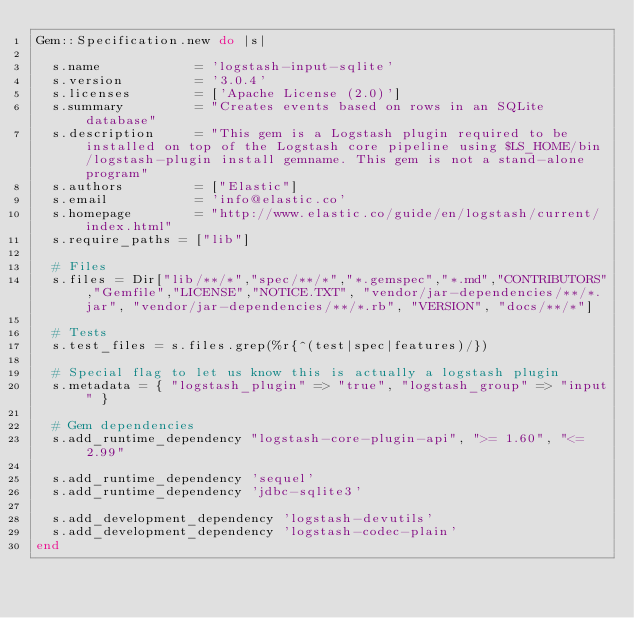Convert code to text. <code><loc_0><loc_0><loc_500><loc_500><_Ruby_>Gem::Specification.new do |s|

  s.name            = 'logstash-input-sqlite'
  s.version         = '3.0.4'
  s.licenses        = ['Apache License (2.0)']
  s.summary         = "Creates events based on rows in an SQLite database"
  s.description     = "This gem is a Logstash plugin required to be installed on top of the Logstash core pipeline using $LS_HOME/bin/logstash-plugin install gemname. This gem is not a stand-alone program"
  s.authors         = ["Elastic"]
  s.email           = 'info@elastic.co'
  s.homepage        = "http://www.elastic.co/guide/en/logstash/current/index.html"
  s.require_paths = ["lib"]

  # Files
  s.files = Dir["lib/**/*","spec/**/*","*.gemspec","*.md","CONTRIBUTORS","Gemfile","LICENSE","NOTICE.TXT", "vendor/jar-dependencies/**/*.jar", "vendor/jar-dependencies/**/*.rb", "VERSION", "docs/**/*"]

  # Tests
  s.test_files = s.files.grep(%r{^(test|spec|features)/})

  # Special flag to let us know this is actually a logstash plugin
  s.metadata = { "logstash_plugin" => "true", "logstash_group" => "input" }

  # Gem dependencies
  s.add_runtime_dependency "logstash-core-plugin-api", ">= 1.60", "<= 2.99"

  s.add_runtime_dependency 'sequel'
  s.add_runtime_dependency 'jdbc-sqlite3'

  s.add_development_dependency 'logstash-devutils'
  s.add_development_dependency 'logstash-codec-plain'
end

</code> 